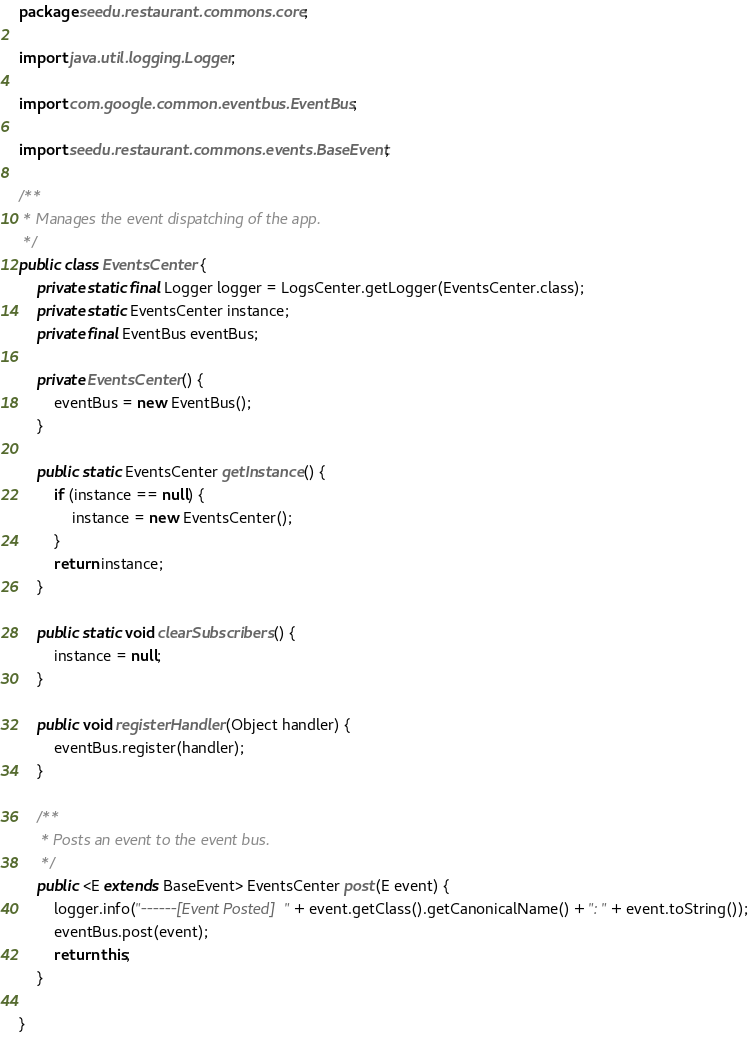<code> <loc_0><loc_0><loc_500><loc_500><_Java_>package seedu.restaurant.commons.core;

import java.util.logging.Logger;

import com.google.common.eventbus.EventBus;

import seedu.restaurant.commons.events.BaseEvent;

/**
 * Manages the event dispatching of the app.
 */
public class EventsCenter {
    private static final Logger logger = LogsCenter.getLogger(EventsCenter.class);
    private static EventsCenter instance;
    private final EventBus eventBus;

    private EventsCenter() {
        eventBus = new EventBus();
    }

    public static EventsCenter getInstance() {
        if (instance == null) {
            instance = new EventsCenter();
        }
        return instance;
    }

    public static void clearSubscribers() {
        instance = null;
    }

    public void registerHandler(Object handler) {
        eventBus.register(handler);
    }

    /**
     * Posts an event to the event bus.
     */
    public <E extends BaseEvent> EventsCenter post(E event) {
        logger.info("------[Event Posted] " + event.getClass().getCanonicalName() + ": " + event.toString());
        eventBus.post(event);
        return this;
    }

}
</code> 